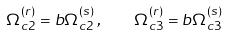<formula> <loc_0><loc_0><loc_500><loc_500>\Omega _ { c 2 } ^ { ( r ) } = b \Omega _ { c 2 } ^ { ( s ) } \, , \quad \Omega _ { c 3 } ^ { ( r ) } = b \Omega _ { c 3 } ^ { ( s ) }</formula> 